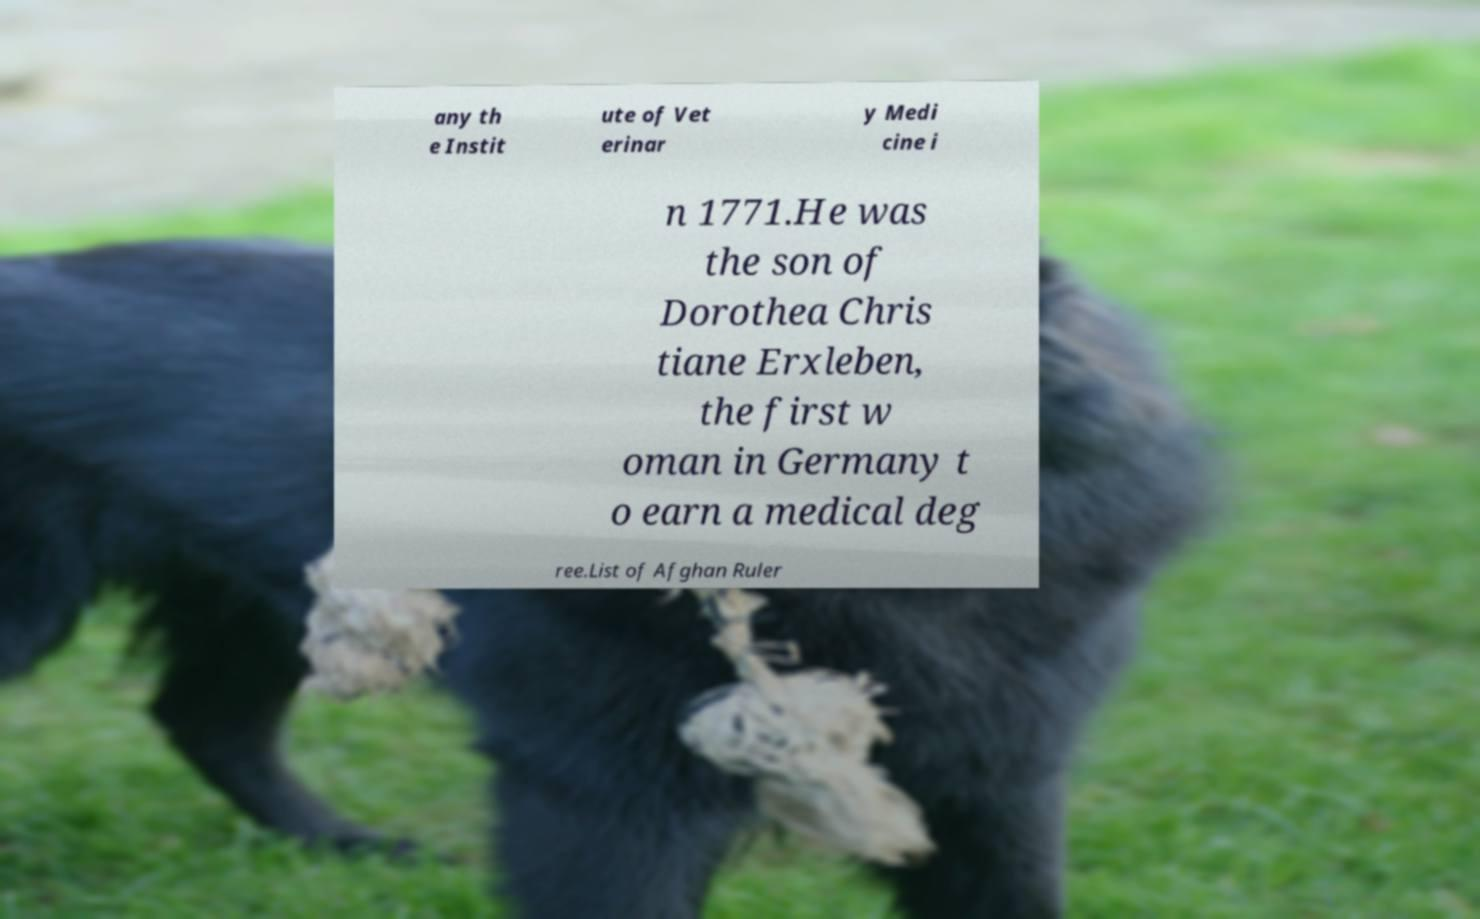Can you accurately transcribe the text from the provided image for me? any th e Instit ute of Vet erinar y Medi cine i n 1771.He was the son of Dorothea Chris tiane Erxleben, the first w oman in Germany t o earn a medical deg ree.List of Afghan Ruler 